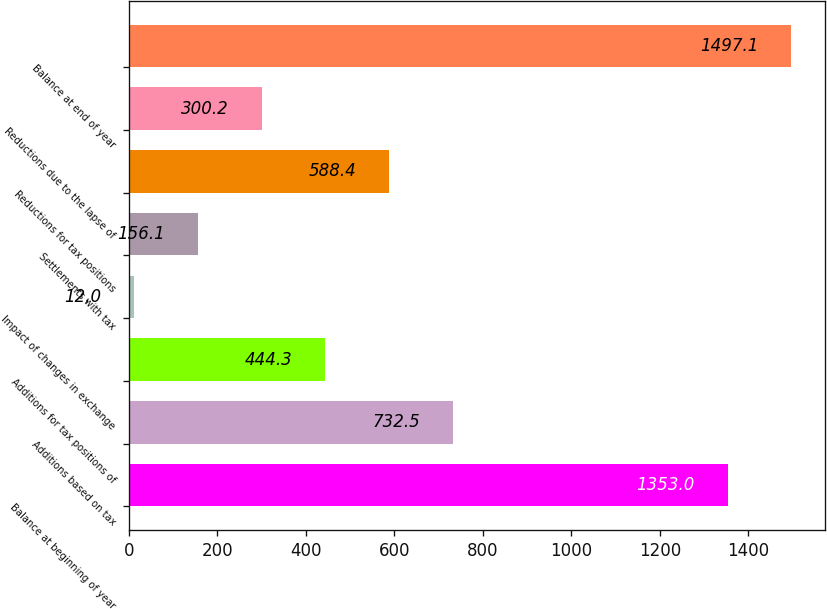Convert chart to OTSL. <chart><loc_0><loc_0><loc_500><loc_500><bar_chart><fcel>Balance at beginning of year<fcel>Additions based on tax<fcel>Additions for tax positions of<fcel>Impact of changes in exchange<fcel>Settlements with tax<fcel>Reductions for tax positions<fcel>Reductions due to the lapse of<fcel>Balance at end of year<nl><fcel>1353<fcel>732.5<fcel>444.3<fcel>12<fcel>156.1<fcel>588.4<fcel>300.2<fcel>1497.1<nl></chart> 